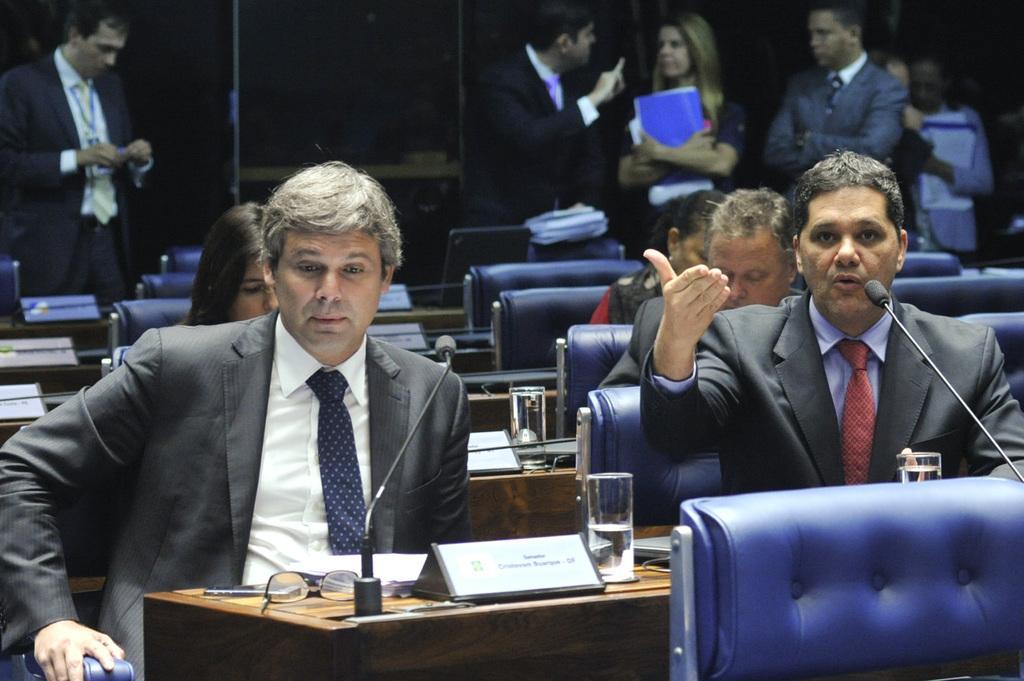Could you give a brief overview of what you see in this image? On the right hand side, there is a person in suit, sitting and speaking. In front of him, there is a mic. There are two people sitting right to him and other two sitting back to him. In the background, group of people standing, some of them are speaking. There are chairs and some other items in the background. 